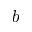Convert formula to latex. <formula><loc_0><loc_0><loc_500><loc_500>b</formula> 